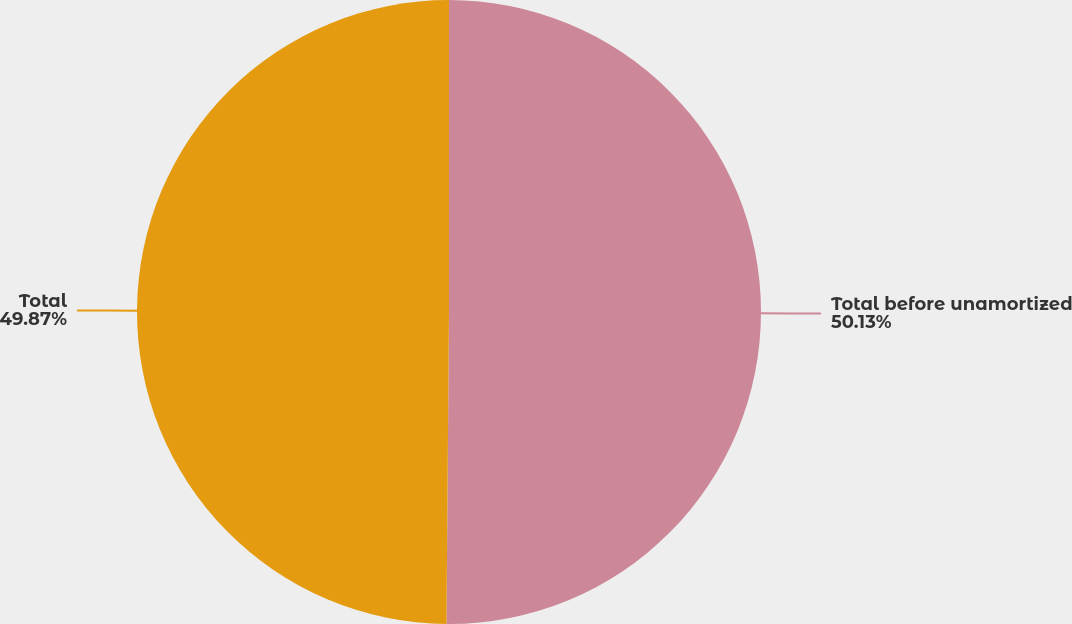<chart> <loc_0><loc_0><loc_500><loc_500><pie_chart><fcel>Total before unamortized<fcel>Total<nl><fcel>50.13%<fcel>49.87%<nl></chart> 